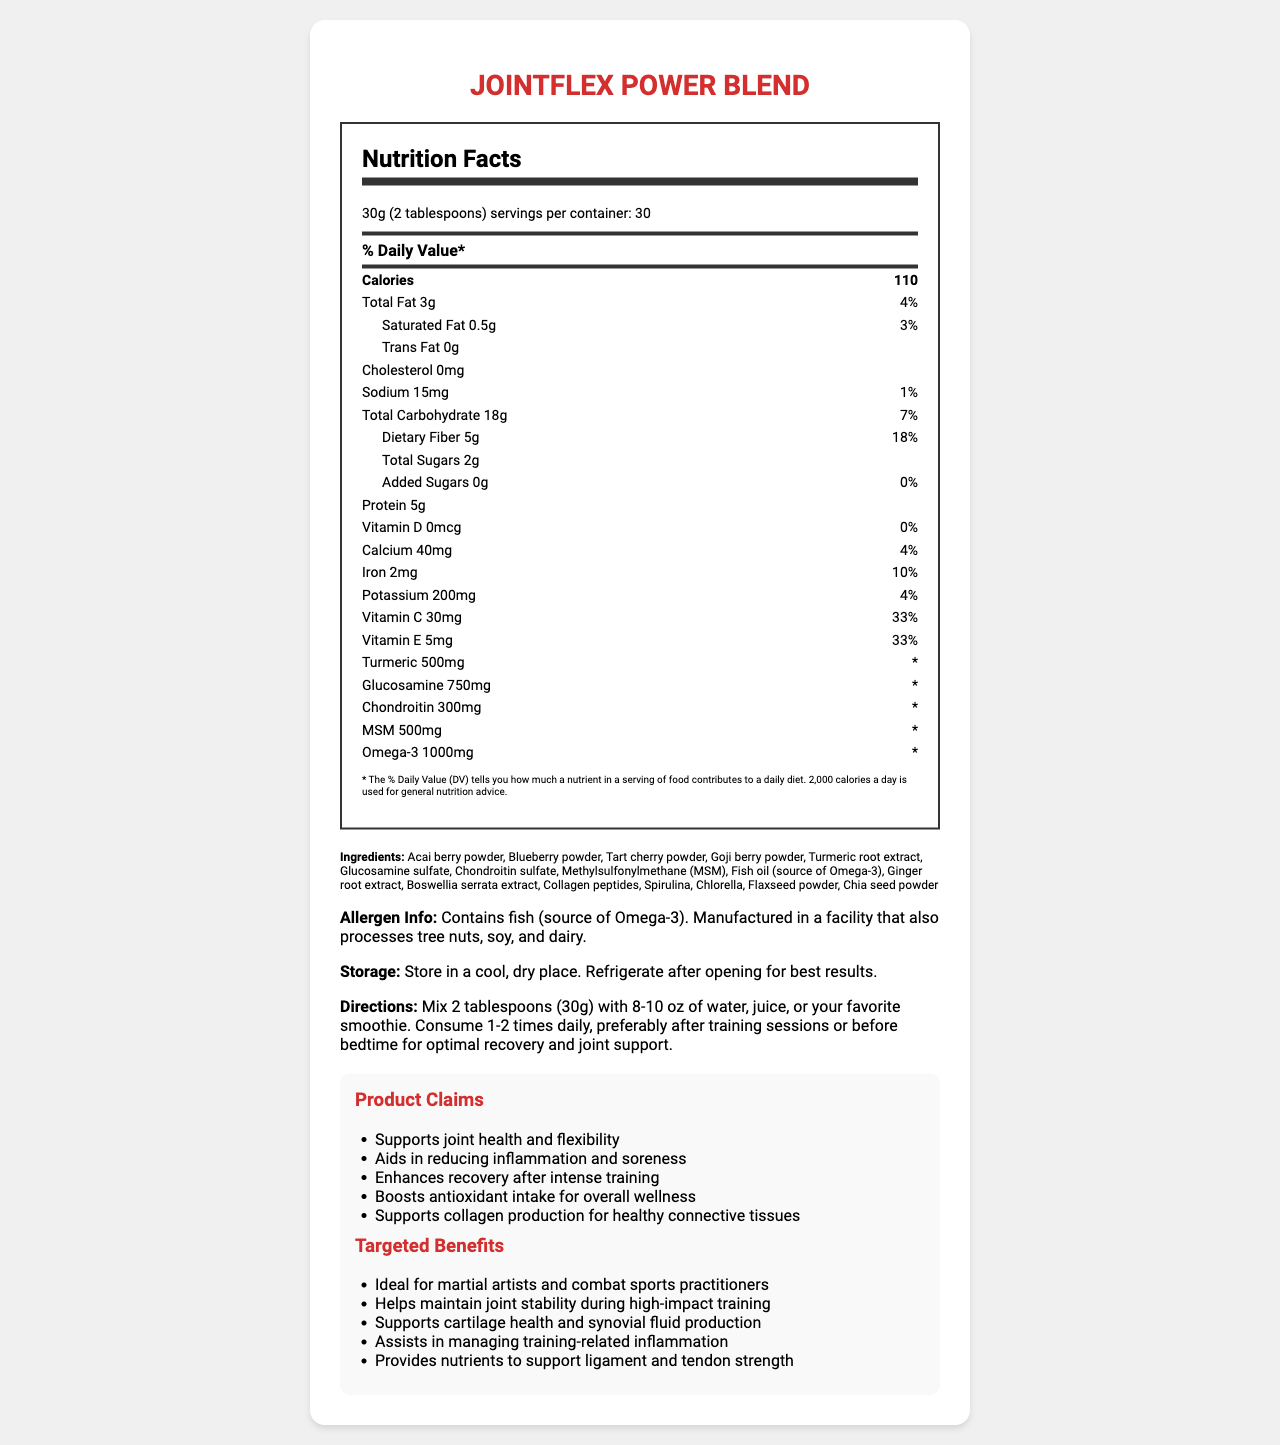what is the serving size of JointFlex Power Blend? The serving size is clearly mentioned in the document as 30g, which equals 2 tablespoons.
Answer: 30g (2 tablespoons) how many calories are in one serving of JointFlex Power Blend? The calorie content per serving is listed as 110 calories.
Answer: 110 what percentage of daily value does dietary fiber contribute per serving? The document states that dietary fiber contributes 18% to the daily value per serving.
Answer: 18% how much protein is in one serving? The protein content per serving is given as 5 grams.
Answer: 5g what is the amount of vitamin C per serving? The document specifies 30mg of vitamin C per serving.
Answer: 30mg how much omega-3 is present in the blend? According to the document, the omega-3 content is 1000mg per serving.
Answer: 1000mg what is the amount of sodium in one serving? The document indicates that there are 15mg of sodium per serving.
Answer: 15mg what are the ingredients in the JointFlex Power Blend? The document provides a comprehensive list of the ingredients included in the blend.
Answer: Acai berry powder, Blueberry powder, Tart cherry powder, Goji berry powder, Turmeric root extract, Glucosamine sulfate, Chondroitin sulfate, Methylsulfonylmethane (MSM), Fish oil (source of Omega-3), Ginger root extract, Boswellia serrata extract, Collagen peptides, Spirulina, Chlorella, Flaxseed powder, Chia seed powder what is the daily value percentage of vitamin E? The document lists the daily value percentage for vitamin E as 33%.
Answer: 33% does the product contain any allergens? The product contains fish (source of Omega-3) and is manufactured in a facility that also processes tree nuts, soy, and dairy.
Answer: Yes which ingredient contributes to joint health? A. Acai berry powder B. Ginger root extract C. Glucosamine sulfate D. Chlorella Glucosamine sulfate is specifically known for its benefits to joint health.
Answer: C what type of dietary fiber is included in the product? A. Soluble B. Insoluble C. Both D. Cannot be determined The type of dietary fiber is not specified in the document, so it cannot be determined.
Answer: D are added sugars included in the product? The document states that the amount of added sugars in the product is 0g.
Answer: No is the product suitable for vegetarians? The presence of fish oil (source of Omega-3) suggests it may not be suitable for vegetarians, but this is not explicitly confirmed in the document.
Answer: Cannot be determined summarize the main information provided in the document. The summary encapsulates the product's purpose, key ingredients, targeted benefits, and important nutritional information.
Answer: JointFlex Power Blend is a superfood blend designed to support joint health and reduce inflammation. It contains ingredients like glucosamine sulfate, chondroitin sulfate, MSM, and omega-3, and is rich in antioxidants. The product provides various nutrients with a focus on joint support, is designed for martial artists, and is intended to enhance recovery. The document also lists specific nutritional information, ingredients, and product claims. 